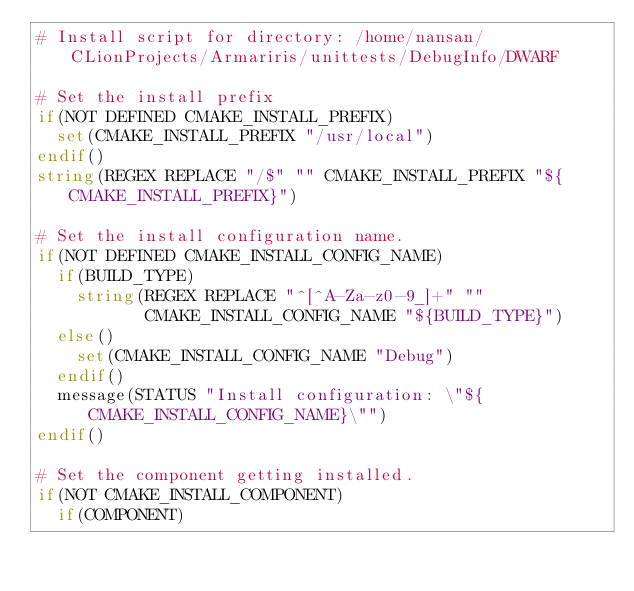Convert code to text. <code><loc_0><loc_0><loc_500><loc_500><_CMake_># Install script for directory: /home/nansan/CLionProjects/Armariris/unittests/DebugInfo/DWARF

# Set the install prefix
if(NOT DEFINED CMAKE_INSTALL_PREFIX)
  set(CMAKE_INSTALL_PREFIX "/usr/local")
endif()
string(REGEX REPLACE "/$" "" CMAKE_INSTALL_PREFIX "${CMAKE_INSTALL_PREFIX}")

# Set the install configuration name.
if(NOT DEFINED CMAKE_INSTALL_CONFIG_NAME)
  if(BUILD_TYPE)
    string(REGEX REPLACE "^[^A-Za-z0-9_]+" ""
           CMAKE_INSTALL_CONFIG_NAME "${BUILD_TYPE}")
  else()
    set(CMAKE_INSTALL_CONFIG_NAME "Debug")
  endif()
  message(STATUS "Install configuration: \"${CMAKE_INSTALL_CONFIG_NAME}\"")
endif()

# Set the component getting installed.
if(NOT CMAKE_INSTALL_COMPONENT)
  if(COMPONENT)</code> 